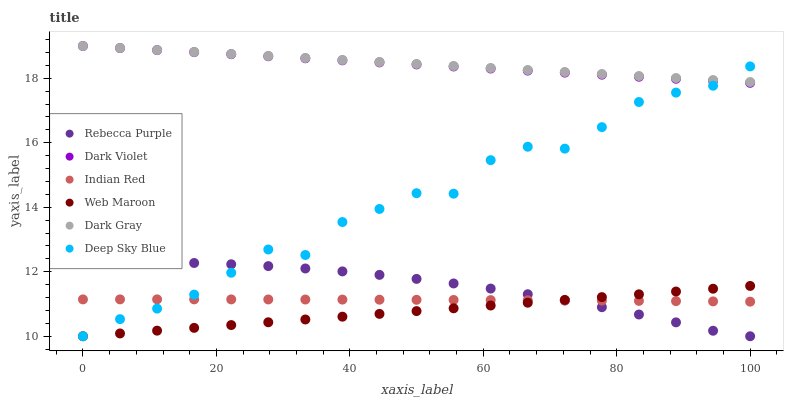Does Web Maroon have the minimum area under the curve?
Answer yes or no. Yes. Does Dark Gray have the maximum area under the curve?
Answer yes or no. Yes. Does Dark Violet have the minimum area under the curve?
Answer yes or no. No. Does Dark Violet have the maximum area under the curve?
Answer yes or no. No. Is Web Maroon the smoothest?
Answer yes or no. Yes. Is Deep Sky Blue the roughest?
Answer yes or no. Yes. Is Dark Violet the smoothest?
Answer yes or no. No. Is Dark Violet the roughest?
Answer yes or no. No. Does Deep Sky Blue have the lowest value?
Answer yes or no. Yes. Does Dark Violet have the lowest value?
Answer yes or no. No. Does Dark Gray have the highest value?
Answer yes or no. Yes. Does Web Maroon have the highest value?
Answer yes or no. No. Is Indian Red less than Dark Violet?
Answer yes or no. Yes. Is Dark Gray greater than Web Maroon?
Answer yes or no. Yes. Does Indian Red intersect Rebecca Purple?
Answer yes or no. Yes. Is Indian Red less than Rebecca Purple?
Answer yes or no. No. Is Indian Red greater than Rebecca Purple?
Answer yes or no. No. Does Indian Red intersect Dark Violet?
Answer yes or no. No. 